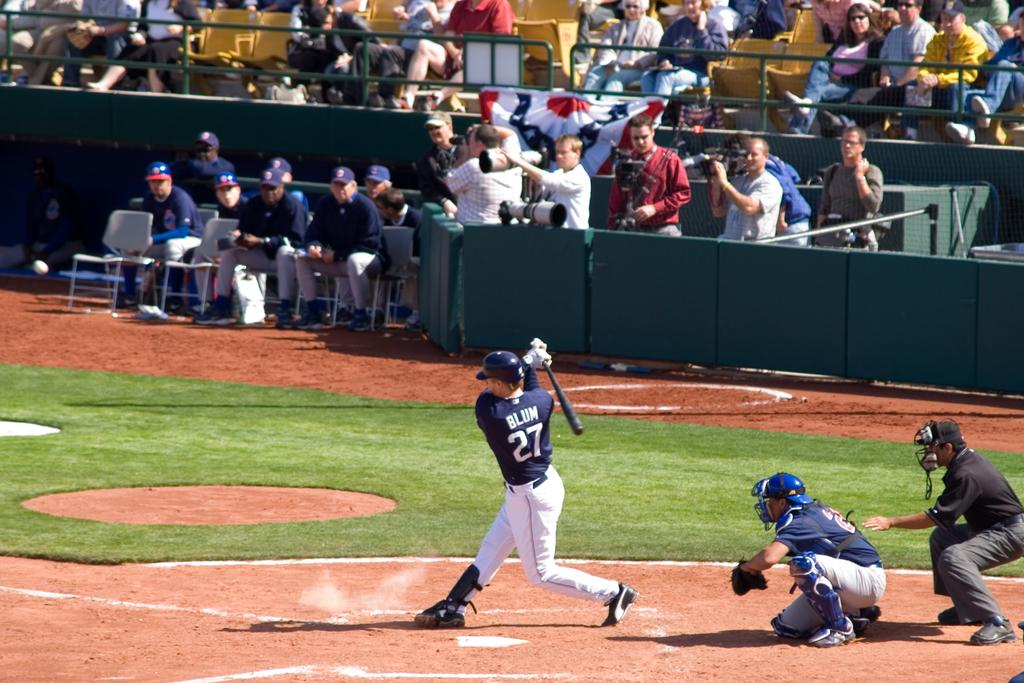<image>
Create a compact narrative representing the image presented. A baseball game in which Blum, number 27 is batting. 